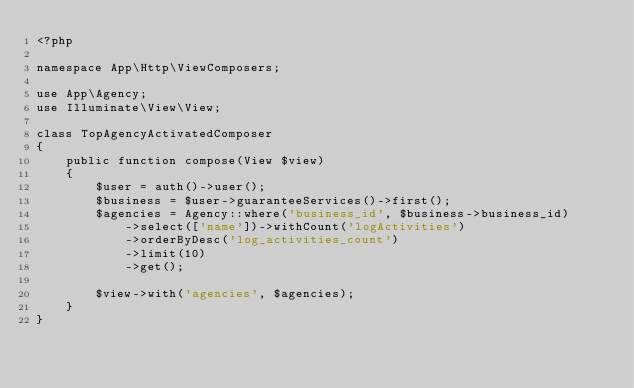<code> <loc_0><loc_0><loc_500><loc_500><_PHP_><?php

namespace App\Http\ViewComposers;

use App\Agency;
use Illuminate\View\View;

class TopAgencyActivatedComposer
{
    public function compose(View $view)
    {
        $user = auth()->user();
        $business = $user->guaranteeServices()->first();
        $agencies = Agency::where('business_id', $business->business_id)
            ->select(['name'])->withCount('logActivities')
            ->orderByDesc('log_activities_count')
            ->limit(10)
            ->get();

        $view->with('agencies', $agencies);
    }
}</code> 